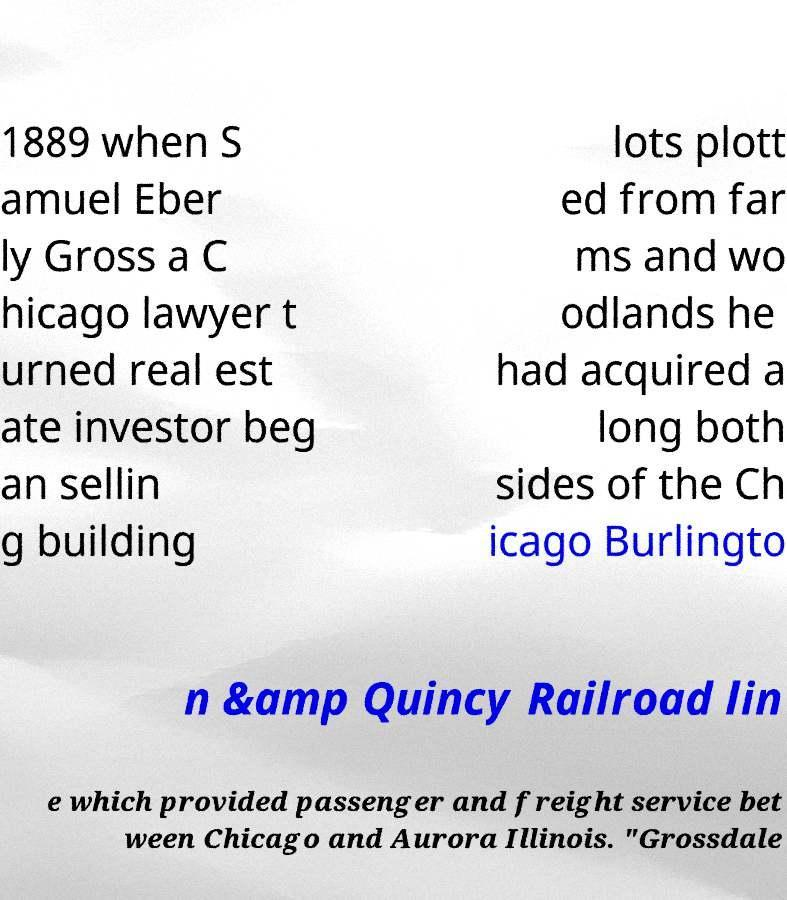There's text embedded in this image that I need extracted. Can you transcribe it verbatim? 1889 when S amuel Eber ly Gross a C hicago lawyer t urned real est ate investor beg an sellin g building lots plott ed from far ms and wo odlands he had acquired a long both sides of the Ch icago Burlingto n &amp Quincy Railroad lin e which provided passenger and freight service bet ween Chicago and Aurora Illinois. "Grossdale 